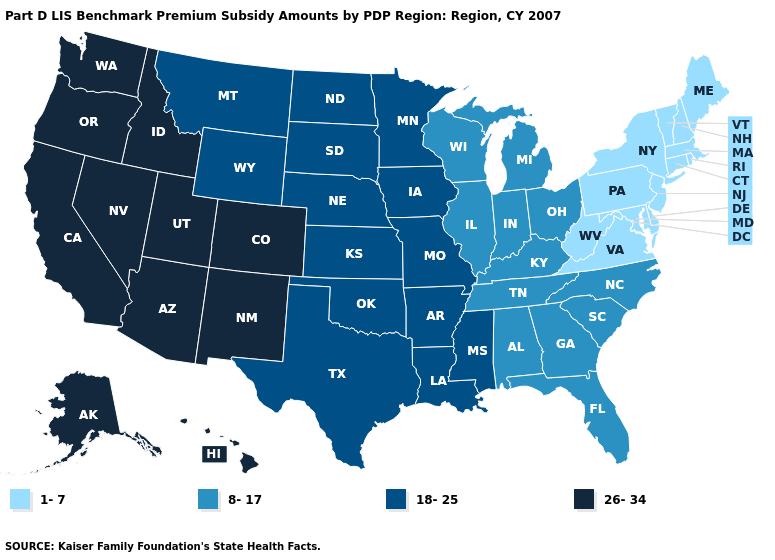What is the value of Massachusetts?
Write a very short answer. 1-7. What is the highest value in the South ?
Concise answer only. 18-25. Name the states that have a value in the range 1-7?
Short answer required. Connecticut, Delaware, Maine, Maryland, Massachusetts, New Hampshire, New Jersey, New York, Pennsylvania, Rhode Island, Vermont, Virginia, West Virginia. Among the states that border Idaho , does Nevada have the highest value?
Concise answer only. Yes. What is the highest value in states that border Wisconsin?
Concise answer only. 18-25. Which states have the lowest value in the USA?
Keep it brief. Connecticut, Delaware, Maine, Maryland, Massachusetts, New Hampshire, New Jersey, New York, Pennsylvania, Rhode Island, Vermont, Virginia, West Virginia. Which states have the lowest value in the USA?
Concise answer only. Connecticut, Delaware, Maine, Maryland, Massachusetts, New Hampshire, New Jersey, New York, Pennsylvania, Rhode Island, Vermont, Virginia, West Virginia. Name the states that have a value in the range 1-7?
Quick response, please. Connecticut, Delaware, Maine, Maryland, Massachusetts, New Hampshire, New Jersey, New York, Pennsylvania, Rhode Island, Vermont, Virginia, West Virginia. What is the lowest value in the USA?
Give a very brief answer. 1-7. Name the states that have a value in the range 1-7?
Keep it brief. Connecticut, Delaware, Maine, Maryland, Massachusetts, New Hampshire, New Jersey, New York, Pennsylvania, Rhode Island, Vermont, Virginia, West Virginia. Among the states that border Oregon , which have the highest value?
Short answer required. California, Idaho, Nevada, Washington. Name the states that have a value in the range 18-25?
Concise answer only. Arkansas, Iowa, Kansas, Louisiana, Minnesota, Mississippi, Missouri, Montana, Nebraska, North Dakota, Oklahoma, South Dakota, Texas, Wyoming. Name the states that have a value in the range 1-7?
Answer briefly. Connecticut, Delaware, Maine, Maryland, Massachusetts, New Hampshire, New Jersey, New York, Pennsylvania, Rhode Island, Vermont, Virginia, West Virginia. Does Oregon have the same value as Michigan?
Concise answer only. No. Does Nebraska have a lower value than California?
Quick response, please. Yes. 